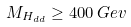Convert formula to latex. <formula><loc_0><loc_0><loc_500><loc_500>M _ { H _ { d d } } \geq 4 0 0 \, G e v</formula> 